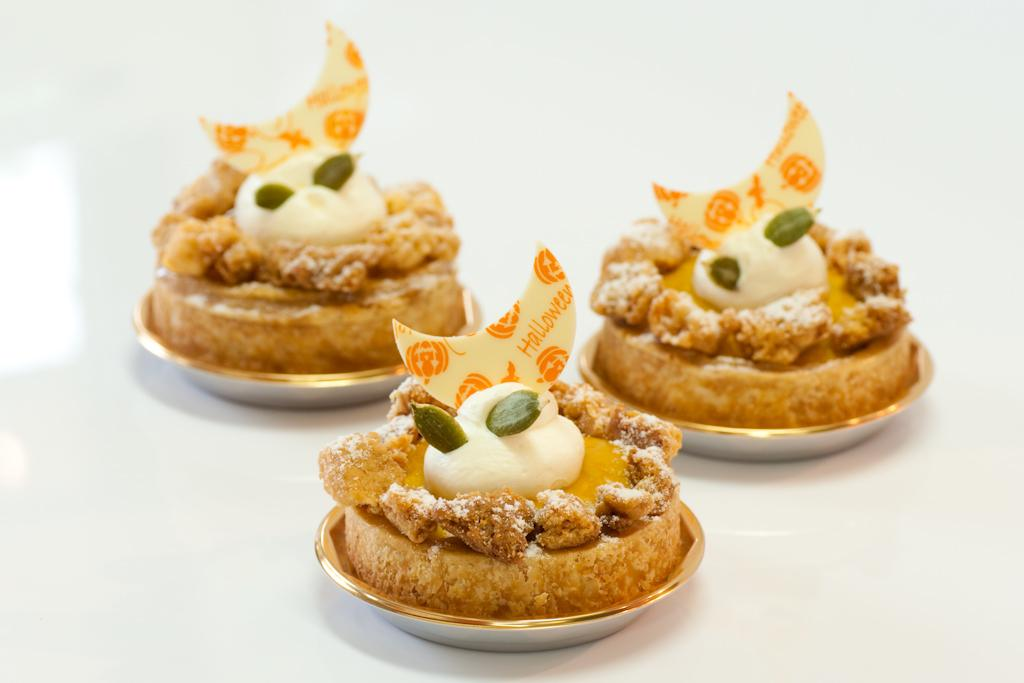What is on the plate that is visible in the image? There are food items on a plate in the image. What color is the background of the image? The background of the image is white. How many dinosaurs can be seen in the image? There are no dinosaurs present in the image. What type of judge is depicted in the image? There is no judge depicted in the image. 